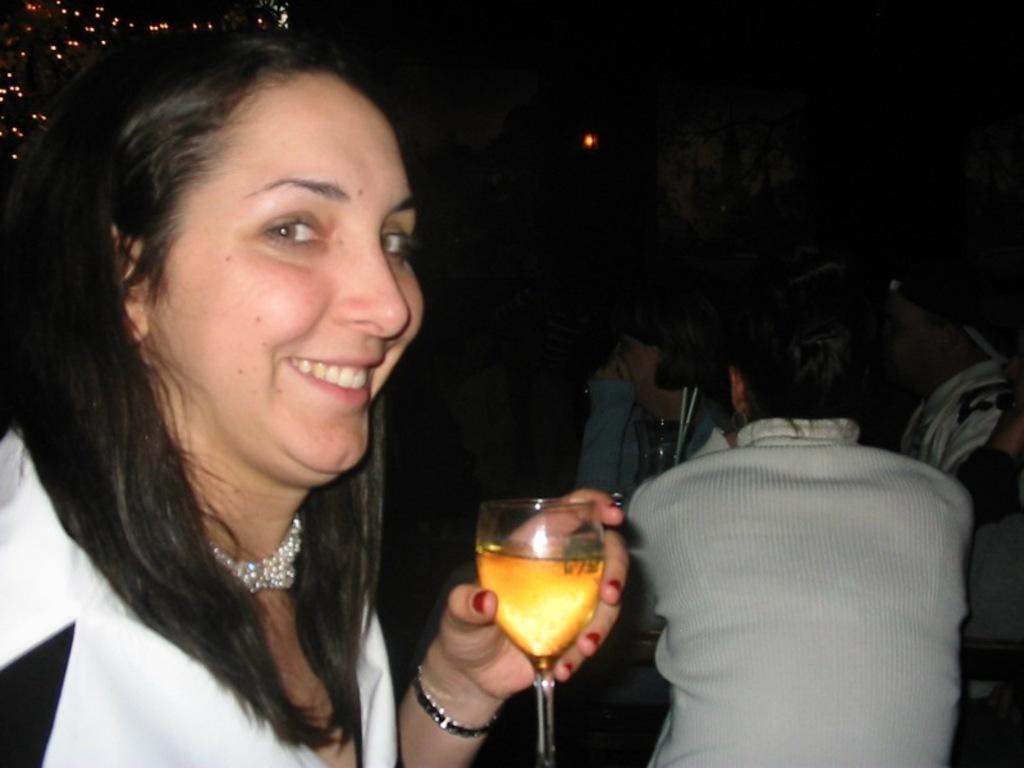Please provide a concise description of this image. In this picture there is a woman standing in front holding a wine glass, smiling and giving a pose into the camera. Behind there is a boy wearing a white t-shirt and sitting on the ground. Behind there is a dark background. 